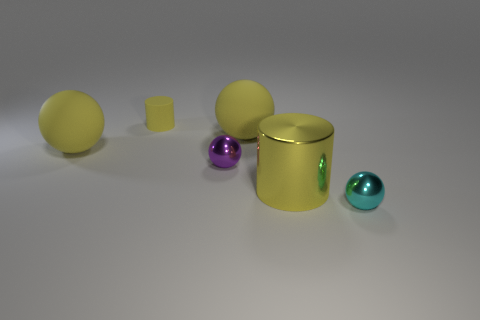Subtract all yellow cylinders. How many were subtracted if there are1yellow cylinders left? 1 Add 2 small purple spheres. How many objects exist? 8 Subtract all cylinders. How many objects are left? 4 Add 5 tiny purple metallic things. How many tiny purple metallic things exist? 6 Subtract 2 yellow spheres. How many objects are left? 4 Subtract all red things. Subtract all purple balls. How many objects are left? 5 Add 3 shiny things. How many shiny things are left? 6 